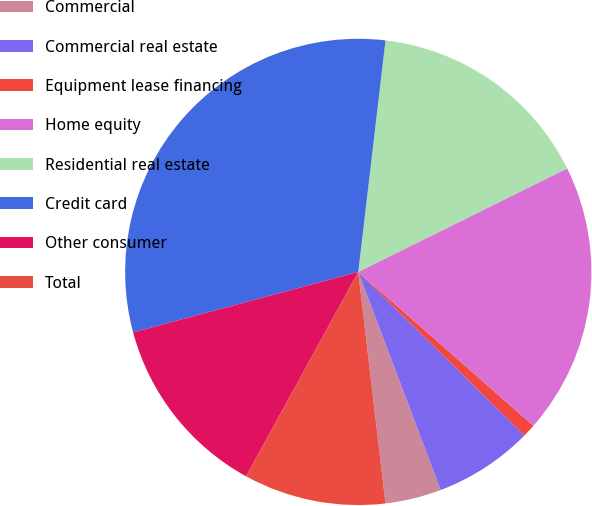<chart> <loc_0><loc_0><loc_500><loc_500><pie_chart><fcel>Commercial<fcel>Commercial real estate<fcel>Equipment lease financing<fcel>Home equity<fcel>Residential real estate<fcel>Credit card<fcel>Other consumer<fcel>Total<nl><fcel>3.89%<fcel>6.87%<fcel>0.91%<fcel>18.79%<fcel>15.81%<fcel>31.04%<fcel>12.83%<fcel>9.85%<nl></chart> 